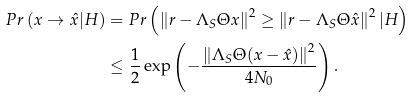<formula> <loc_0><loc_0><loc_500><loc_500>P r \left ( x \rightarrow \hat { x } | H \right ) & = P r \left ( \left \| r - \Lambda _ { S } \Theta x \right \| ^ { 2 } \geq \left \| r - \Lambda _ { S } \Theta \hat { x } \right \| ^ { 2 } | H \right ) \\ & \leq \frac { 1 } { 2 } \exp \left ( - \frac { \left \| \Lambda _ { S } \Theta ( x - \hat { x } ) \right \| ^ { 2 } } { 4 N _ { 0 } } \right ) .</formula> 